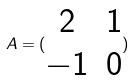Convert formula to latex. <formula><loc_0><loc_0><loc_500><loc_500>A = ( \begin{matrix} 2 & 1 \\ - 1 & 0 \end{matrix} )</formula> 